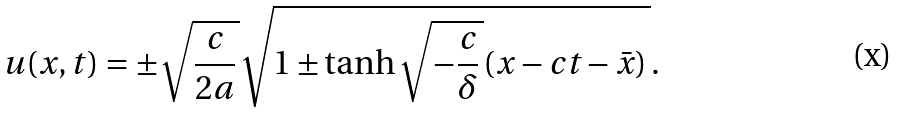<formula> <loc_0><loc_0><loc_500><loc_500>u ( x , t ) = \pm \sqrt { \frac { c } { 2 a } \, } \sqrt { 1 \pm \tanh \sqrt { - \frac { c } { \delta } \, } ( x - c t - \bar { x } ) \, } .</formula> 